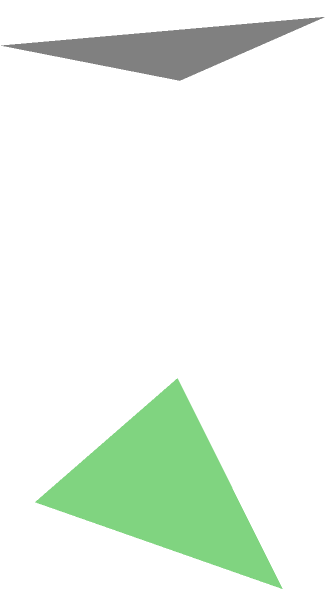A triangular prism represents the three sides of a new family dynamic: you, your child, and your potential new partner. The base of the prism has dimensions of 4 units and 3 units, while the height of the prism is 5 units. Calculate the total surface area of this prism, symbolizing the total effort needed to create a strong blended family. To calculate the total surface area of the triangular prism, we need to:

1. Calculate the area of the two triangular bases:
   Base area = $\frac{1}{2} \times 4 \times 3 = 6$ square units
   Total base area = $2 \times 6 = 12$ square units

2. Calculate the areas of the three rectangular sides:
   Side 1: $4 \times 5 = 20$ square units
   Side 2: $3 \times 5 = 15$ square units
   Side 3: $5 \times \sqrt{4^2 + 3^2} = 5 \times 5 = 25$ square units
   (Using the Pythagorean theorem to find the hypotenuse: $\sqrt{4^2 + 3^2} = 5$)

3. Sum up all the areas:
   Total surface area = Area of bases + Area of sides
   $= 12 + 20 + 15 + 25 = 72$ square units

This total surface area represents the combined effort and commitment required from all three family members to build a strong blended family.
Answer: 72 square units 